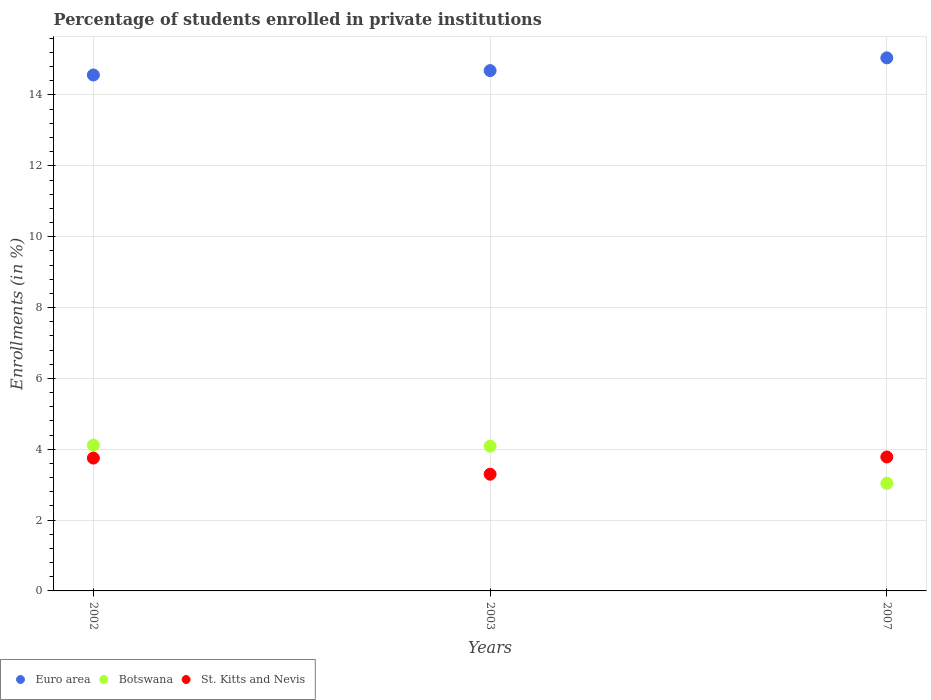What is the percentage of trained teachers in Botswana in 2007?
Offer a terse response. 3.04. Across all years, what is the maximum percentage of trained teachers in Botswana?
Provide a succinct answer. 4.12. Across all years, what is the minimum percentage of trained teachers in St. Kitts and Nevis?
Provide a short and direct response. 3.29. What is the total percentage of trained teachers in Euro area in the graph?
Provide a short and direct response. 44.3. What is the difference between the percentage of trained teachers in Euro area in 2002 and that in 2003?
Offer a very short reply. -0.12. What is the difference between the percentage of trained teachers in St. Kitts and Nevis in 2002 and the percentage of trained teachers in Botswana in 2003?
Your answer should be compact. -0.34. What is the average percentage of trained teachers in Botswana per year?
Your response must be concise. 3.75. In the year 2007, what is the difference between the percentage of trained teachers in St. Kitts and Nevis and percentage of trained teachers in Botswana?
Give a very brief answer. 0.74. In how many years, is the percentage of trained teachers in Euro area greater than 12.4 %?
Give a very brief answer. 3. What is the ratio of the percentage of trained teachers in Botswana in 2002 to that in 2003?
Make the answer very short. 1.01. Is the percentage of trained teachers in St. Kitts and Nevis in 2002 less than that in 2007?
Your answer should be very brief. Yes. What is the difference between the highest and the second highest percentage of trained teachers in St. Kitts and Nevis?
Ensure brevity in your answer.  0.03. What is the difference between the highest and the lowest percentage of trained teachers in St. Kitts and Nevis?
Offer a very short reply. 0.49. In how many years, is the percentage of trained teachers in Botswana greater than the average percentage of trained teachers in Botswana taken over all years?
Provide a short and direct response. 2. Is the sum of the percentage of trained teachers in Euro area in 2002 and 2003 greater than the maximum percentage of trained teachers in St. Kitts and Nevis across all years?
Provide a succinct answer. Yes. Does the percentage of trained teachers in Euro area monotonically increase over the years?
Give a very brief answer. Yes. Is the percentage of trained teachers in Euro area strictly less than the percentage of trained teachers in St. Kitts and Nevis over the years?
Ensure brevity in your answer.  No. What is the difference between two consecutive major ticks on the Y-axis?
Keep it short and to the point. 2. Are the values on the major ticks of Y-axis written in scientific E-notation?
Offer a terse response. No. Does the graph contain any zero values?
Make the answer very short. No. Does the graph contain grids?
Provide a short and direct response. Yes. How many legend labels are there?
Keep it short and to the point. 3. What is the title of the graph?
Provide a succinct answer. Percentage of students enrolled in private institutions. What is the label or title of the Y-axis?
Make the answer very short. Enrollments (in %). What is the Enrollments (in %) in Euro area in 2002?
Your answer should be very brief. 14.56. What is the Enrollments (in %) in Botswana in 2002?
Your answer should be very brief. 4.12. What is the Enrollments (in %) of St. Kitts and Nevis in 2002?
Offer a very short reply. 3.75. What is the Enrollments (in %) of Euro area in 2003?
Ensure brevity in your answer.  14.69. What is the Enrollments (in %) of Botswana in 2003?
Your answer should be compact. 4.09. What is the Enrollments (in %) in St. Kitts and Nevis in 2003?
Your answer should be very brief. 3.29. What is the Enrollments (in %) of Euro area in 2007?
Offer a terse response. 15.05. What is the Enrollments (in %) in Botswana in 2007?
Provide a short and direct response. 3.04. What is the Enrollments (in %) in St. Kitts and Nevis in 2007?
Your answer should be compact. 3.78. Across all years, what is the maximum Enrollments (in %) in Euro area?
Keep it short and to the point. 15.05. Across all years, what is the maximum Enrollments (in %) of Botswana?
Your answer should be compact. 4.12. Across all years, what is the maximum Enrollments (in %) of St. Kitts and Nevis?
Provide a succinct answer. 3.78. Across all years, what is the minimum Enrollments (in %) of Euro area?
Your response must be concise. 14.56. Across all years, what is the minimum Enrollments (in %) of Botswana?
Your answer should be compact. 3.04. Across all years, what is the minimum Enrollments (in %) of St. Kitts and Nevis?
Make the answer very short. 3.29. What is the total Enrollments (in %) of Euro area in the graph?
Your response must be concise. 44.3. What is the total Enrollments (in %) in Botswana in the graph?
Make the answer very short. 11.24. What is the total Enrollments (in %) in St. Kitts and Nevis in the graph?
Provide a succinct answer. 10.83. What is the difference between the Enrollments (in %) in Euro area in 2002 and that in 2003?
Your response must be concise. -0.12. What is the difference between the Enrollments (in %) in Botswana in 2002 and that in 2003?
Your response must be concise. 0.03. What is the difference between the Enrollments (in %) in St. Kitts and Nevis in 2002 and that in 2003?
Provide a short and direct response. 0.46. What is the difference between the Enrollments (in %) of Euro area in 2002 and that in 2007?
Make the answer very short. -0.48. What is the difference between the Enrollments (in %) in Botswana in 2002 and that in 2007?
Your answer should be compact. 1.08. What is the difference between the Enrollments (in %) of St. Kitts and Nevis in 2002 and that in 2007?
Give a very brief answer. -0.03. What is the difference between the Enrollments (in %) in Euro area in 2003 and that in 2007?
Provide a short and direct response. -0.36. What is the difference between the Enrollments (in %) in Botswana in 2003 and that in 2007?
Your answer should be very brief. 1.05. What is the difference between the Enrollments (in %) of St. Kitts and Nevis in 2003 and that in 2007?
Provide a succinct answer. -0.49. What is the difference between the Enrollments (in %) of Euro area in 2002 and the Enrollments (in %) of Botswana in 2003?
Keep it short and to the point. 10.48. What is the difference between the Enrollments (in %) of Euro area in 2002 and the Enrollments (in %) of St. Kitts and Nevis in 2003?
Offer a very short reply. 11.27. What is the difference between the Enrollments (in %) of Botswana in 2002 and the Enrollments (in %) of St. Kitts and Nevis in 2003?
Your answer should be very brief. 0.82. What is the difference between the Enrollments (in %) in Euro area in 2002 and the Enrollments (in %) in Botswana in 2007?
Your answer should be very brief. 11.53. What is the difference between the Enrollments (in %) in Euro area in 2002 and the Enrollments (in %) in St. Kitts and Nevis in 2007?
Give a very brief answer. 10.78. What is the difference between the Enrollments (in %) of Botswana in 2002 and the Enrollments (in %) of St. Kitts and Nevis in 2007?
Your answer should be compact. 0.33. What is the difference between the Enrollments (in %) in Euro area in 2003 and the Enrollments (in %) in Botswana in 2007?
Your response must be concise. 11.65. What is the difference between the Enrollments (in %) in Euro area in 2003 and the Enrollments (in %) in St. Kitts and Nevis in 2007?
Ensure brevity in your answer.  10.91. What is the difference between the Enrollments (in %) in Botswana in 2003 and the Enrollments (in %) in St. Kitts and Nevis in 2007?
Give a very brief answer. 0.31. What is the average Enrollments (in %) in Euro area per year?
Your answer should be very brief. 14.77. What is the average Enrollments (in %) in Botswana per year?
Make the answer very short. 3.75. What is the average Enrollments (in %) in St. Kitts and Nevis per year?
Provide a short and direct response. 3.61. In the year 2002, what is the difference between the Enrollments (in %) of Euro area and Enrollments (in %) of Botswana?
Your answer should be compact. 10.45. In the year 2002, what is the difference between the Enrollments (in %) in Euro area and Enrollments (in %) in St. Kitts and Nevis?
Give a very brief answer. 10.81. In the year 2002, what is the difference between the Enrollments (in %) in Botswana and Enrollments (in %) in St. Kitts and Nevis?
Provide a succinct answer. 0.37. In the year 2003, what is the difference between the Enrollments (in %) of Euro area and Enrollments (in %) of Botswana?
Make the answer very short. 10.6. In the year 2003, what is the difference between the Enrollments (in %) in Euro area and Enrollments (in %) in St. Kitts and Nevis?
Provide a short and direct response. 11.39. In the year 2003, what is the difference between the Enrollments (in %) of Botswana and Enrollments (in %) of St. Kitts and Nevis?
Provide a short and direct response. 0.79. In the year 2007, what is the difference between the Enrollments (in %) in Euro area and Enrollments (in %) in Botswana?
Your response must be concise. 12.01. In the year 2007, what is the difference between the Enrollments (in %) of Euro area and Enrollments (in %) of St. Kitts and Nevis?
Make the answer very short. 11.27. In the year 2007, what is the difference between the Enrollments (in %) in Botswana and Enrollments (in %) in St. Kitts and Nevis?
Offer a very short reply. -0.74. What is the ratio of the Enrollments (in %) of St. Kitts and Nevis in 2002 to that in 2003?
Your answer should be very brief. 1.14. What is the ratio of the Enrollments (in %) in Euro area in 2002 to that in 2007?
Give a very brief answer. 0.97. What is the ratio of the Enrollments (in %) of Botswana in 2002 to that in 2007?
Ensure brevity in your answer.  1.35. What is the ratio of the Enrollments (in %) in St. Kitts and Nevis in 2002 to that in 2007?
Your answer should be very brief. 0.99. What is the ratio of the Enrollments (in %) of Euro area in 2003 to that in 2007?
Make the answer very short. 0.98. What is the ratio of the Enrollments (in %) of Botswana in 2003 to that in 2007?
Your answer should be very brief. 1.35. What is the ratio of the Enrollments (in %) in St. Kitts and Nevis in 2003 to that in 2007?
Give a very brief answer. 0.87. What is the difference between the highest and the second highest Enrollments (in %) of Euro area?
Keep it short and to the point. 0.36. What is the difference between the highest and the second highest Enrollments (in %) of Botswana?
Your answer should be compact. 0.03. What is the difference between the highest and the second highest Enrollments (in %) of St. Kitts and Nevis?
Keep it short and to the point. 0.03. What is the difference between the highest and the lowest Enrollments (in %) in Euro area?
Offer a very short reply. 0.48. What is the difference between the highest and the lowest Enrollments (in %) in Botswana?
Your answer should be compact. 1.08. What is the difference between the highest and the lowest Enrollments (in %) of St. Kitts and Nevis?
Make the answer very short. 0.49. 